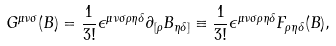Convert formula to latex. <formula><loc_0><loc_0><loc_500><loc_500>G ^ { { \mu } { \nu } { \sigma } } ( B ) = { \frac { 1 } { 3 ! } } { \epsilon } ^ { { \mu } { \nu } { \sigma } { \rho } { \eta } { \delta } } { \partial } _ { [ { \rho } } B _ { { \eta } { \delta } ] } \equiv \frac { 1 } { 3 ! } { \epsilon } ^ { { \mu } { \nu } { \sigma } { \rho } { \eta } { \delta } } F _ { { \rho } { \eta } { \delta } } ( B ) ,</formula> 